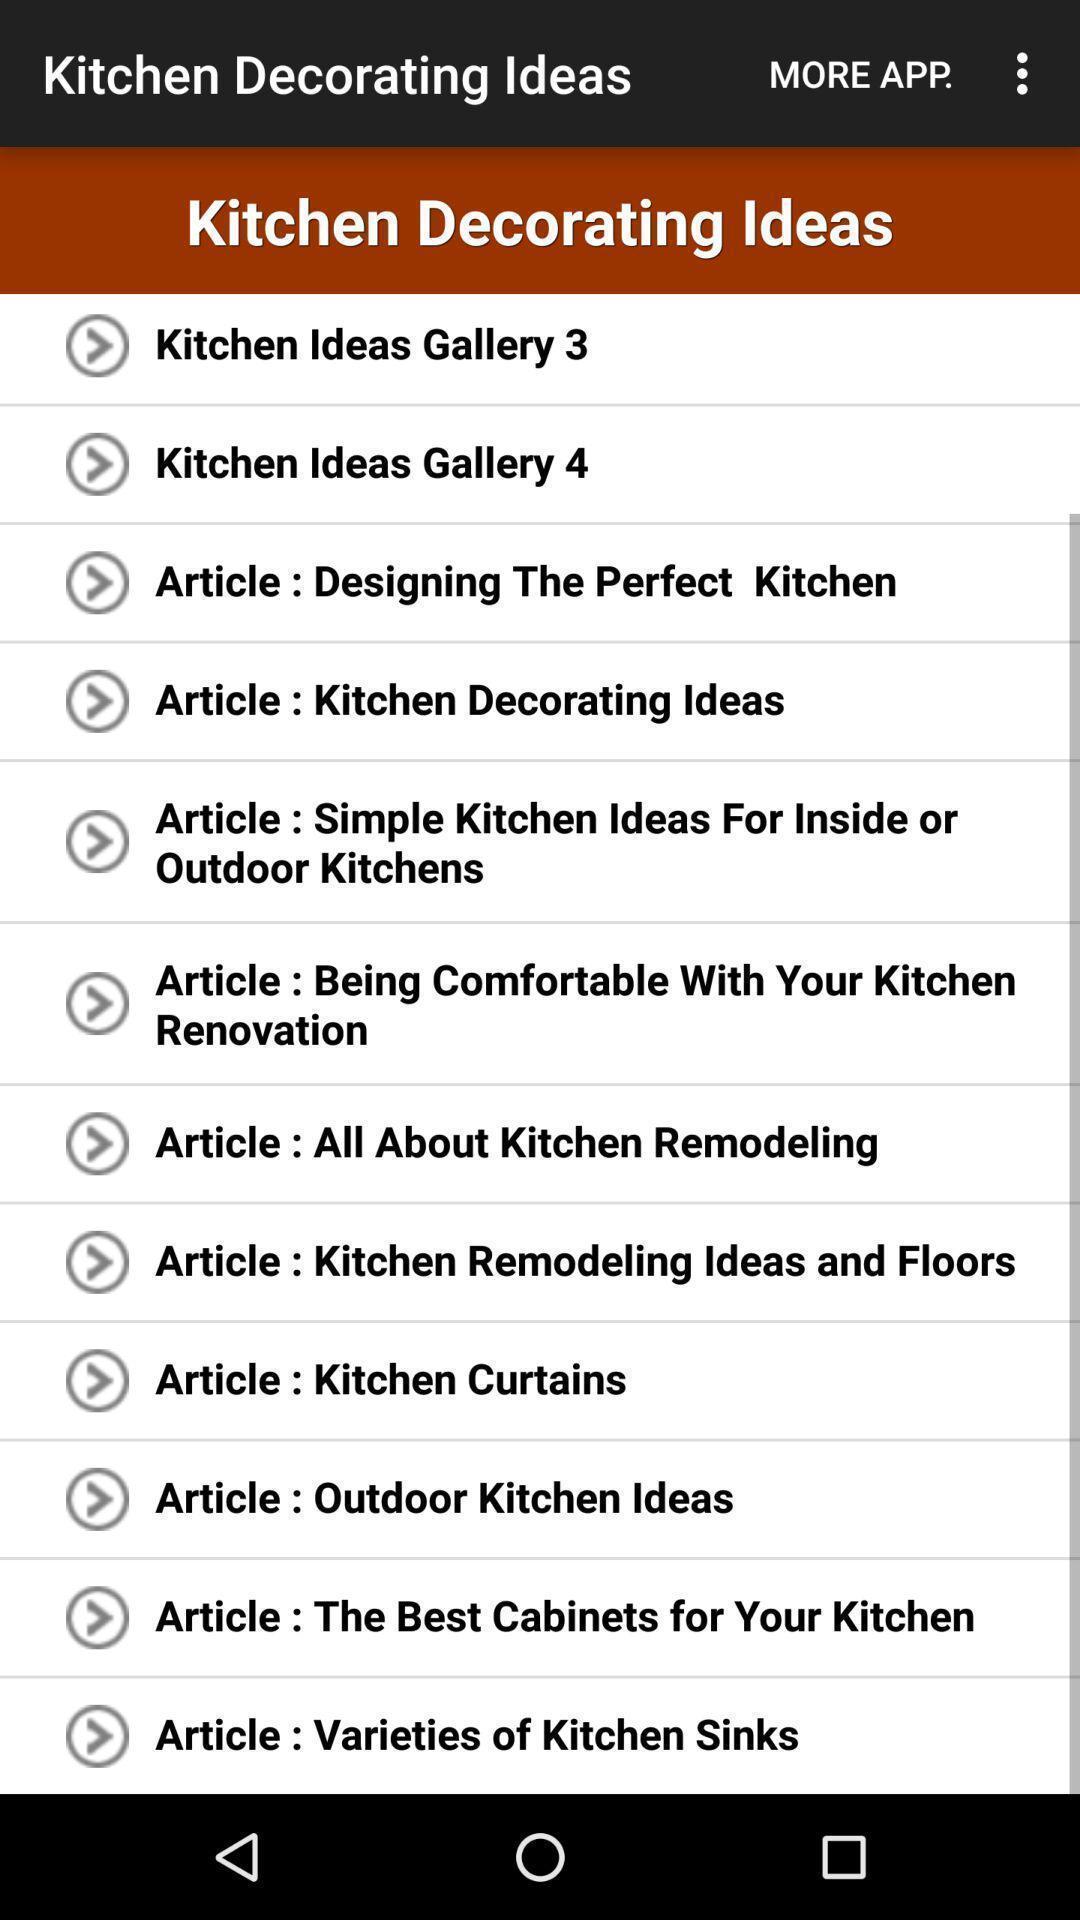Tell me about the visual elements in this screen capture. Screen shows about kitchen decorating ideas. 